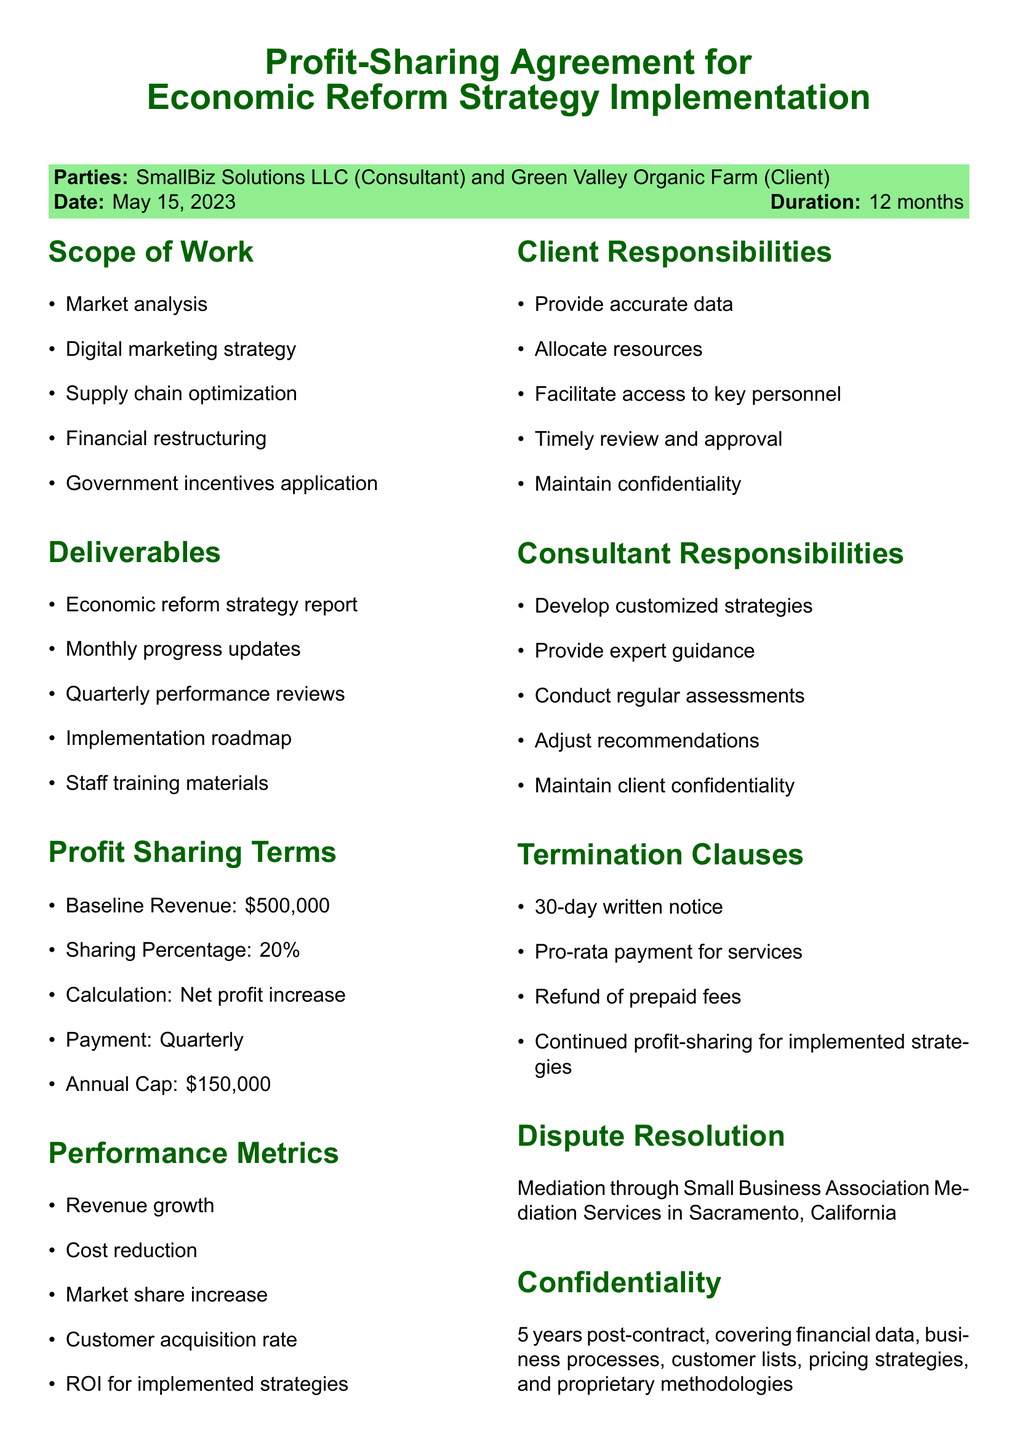What is the title of the document? The title of the document is explicitly stated at the beginning of the document.
Answer: Profit-Sharing Agreement for Economic Reform Strategy Implementation Who are the parties involved in the agreement? The parties are mentioned at the start of the document in the context of the agreement.
Answer: SmallBiz Solutions LLC and Green Valley Organic Farm When was the agreement signed? The agreement date is specified in the document as part of the introductory information.
Answer: May 15, 2023 What is the profit-sharing percentage? This figure is outlined in the profit sharing terms section of the document.
Answer: 20% What is the cap on profit sharing per annum? The maximum limit for profit sharing is stated under profit-sharing terms.
Answer: $150,000 per annum What are the consultant's responsibilities? The document lists the consultant's obligations in a dedicated section.
Answer: Develop customized economic reform strategies What is the duration of the contract? The duration can be found in the introductory portion of the document.
Answer: 12 months What method is used for dispute resolution? The mediation process is described in the dispute resolution section.
Answer: Mediation How long is the confidentiality clause effective after termination? The duration for confidentiality is specified in that section of the document.
Answer: 5 years post-contract termination 